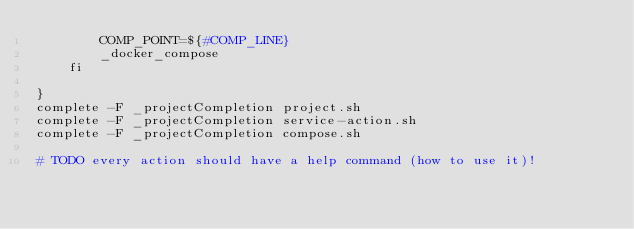<code> <loc_0><loc_0><loc_500><loc_500><_Bash_>        COMP_POINT=${#COMP_LINE}
        _docker_compose
    fi

}
complete -F _projectCompletion project.sh
complete -F _projectCompletion service-action.sh
complete -F _projectCompletion compose.sh

# TODO every action should have a help command (how to use it)!</code> 